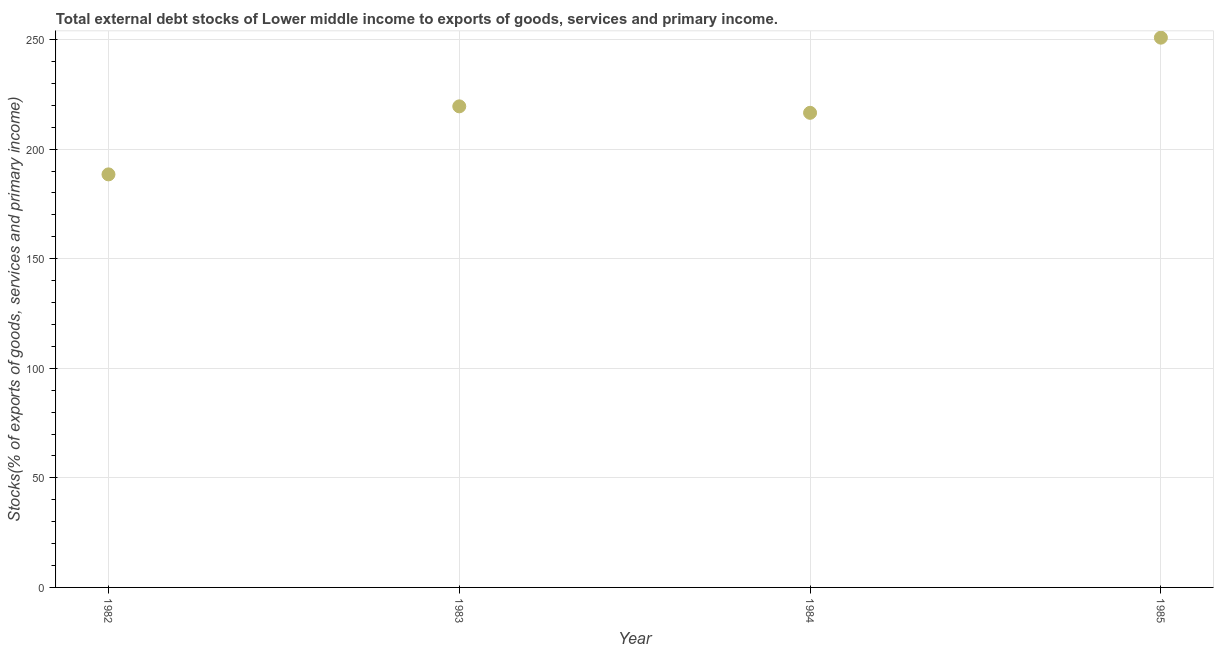What is the external debt stocks in 1985?
Your response must be concise. 250.86. Across all years, what is the maximum external debt stocks?
Provide a short and direct response. 250.86. Across all years, what is the minimum external debt stocks?
Your response must be concise. 188.47. In which year was the external debt stocks maximum?
Keep it short and to the point. 1985. What is the sum of the external debt stocks?
Give a very brief answer. 875.4. What is the difference between the external debt stocks in 1982 and 1984?
Provide a short and direct response. -28.09. What is the average external debt stocks per year?
Keep it short and to the point. 218.85. What is the median external debt stocks?
Your answer should be compact. 218.04. What is the ratio of the external debt stocks in 1984 to that in 1985?
Provide a short and direct response. 0.86. Is the difference between the external debt stocks in 1984 and 1985 greater than the difference between any two years?
Your response must be concise. No. What is the difference between the highest and the second highest external debt stocks?
Provide a succinct answer. 31.34. What is the difference between the highest and the lowest external debt stocks?
Provide a succinct answer. 62.38. In how many years, is the external debt stocks greater than the average external debt stocks taken over all years?
Offer a terse response. 2. Does the external debt stocks monotonically increase over the years?
Your answer should be very brief. No. What is the difference between two consecutive major ticks on the Y-axis?
Keep it short and to the point. 50. Are the values on the major ticks of Y-axis written in scientific E-notation?
Make the answer very short. No. Does the graph contain any zero values?
Provide a short and direct response. No. What is the title of the graph?
Make the answer very short. Total external debt stocks of Lower middle income to exports of goods, services and primary income. What is the label or title of the X-axis?
Your answer should be compact. Year. What is the label or title of the Y-axis?
Ensure brevity in your answer.  Stocks(% of exports of goods, services and primary income). What is the Stocks(% of exports of goods, services and primary income) in 1982?
Your answer should be compact. 188.47. What is the Stocks(% of exports of goods, services and primary income) in 1983?
Provide a succinct answer. 219.51. What is the Stocks(% of exports of goods, services and primary income) in 1984?
Give a very brief answer. 216.56. What is the Stocks(% of exports of goods, services and primary income) in 1985?
Provide a short and direct response. 250.86. What is the difference between the Stocks(% of exports of goods, services and primary income) in 1982 and 1983?
Provide a succinct answer. -31.04. What is the difference between the Stocks(% of exports of goods, services and primary income) in 1982 and 1984?
Your answer should be very brief. -28.09. What is the difference between the Stocks(% of exports of goods, services and primary income) in 1982 and 1985?
Offer a terse response. -62.38. What is the difference between the Stocks(% of exports of goods, services and primary income) in 1983 and 1984?
Your answer should be compact. 2.95. What is the difference between the Stocks(% of exports of goods, services and primary income) in 1983 and 1985?
Give a very brief answer. -31.34. What is the difference between the Stocks(% of exports of goods, services and primary income) in 1984 and 1985?
Keep it short and to the point. -34.29. What is the ratio of the Stocks(% of exports of goods, services and primary income) in 1982 to that in 1983?
Your answer should be very brief. 0.86. What is the ratio of the Stocks(% of exports of goods, services and primary income) in 1982 to that in 1984?
Your answer should be very brief. 0.87. What is the ratio of the Stocks(% of exports of goods, services and primary income) in 1982 to that in 1985?
Keep it short and to the point. 0.75. What is the ratio of the Stocks(% of exports of goods, services and primary income) in 1983 to that in 1984?
Make the answer very short. 1.01. What is the ratio of the Stocks(% of exports of goods, services and primary income) in 1984 to that in 1985?
Keep it short and to the point. 0.86. 